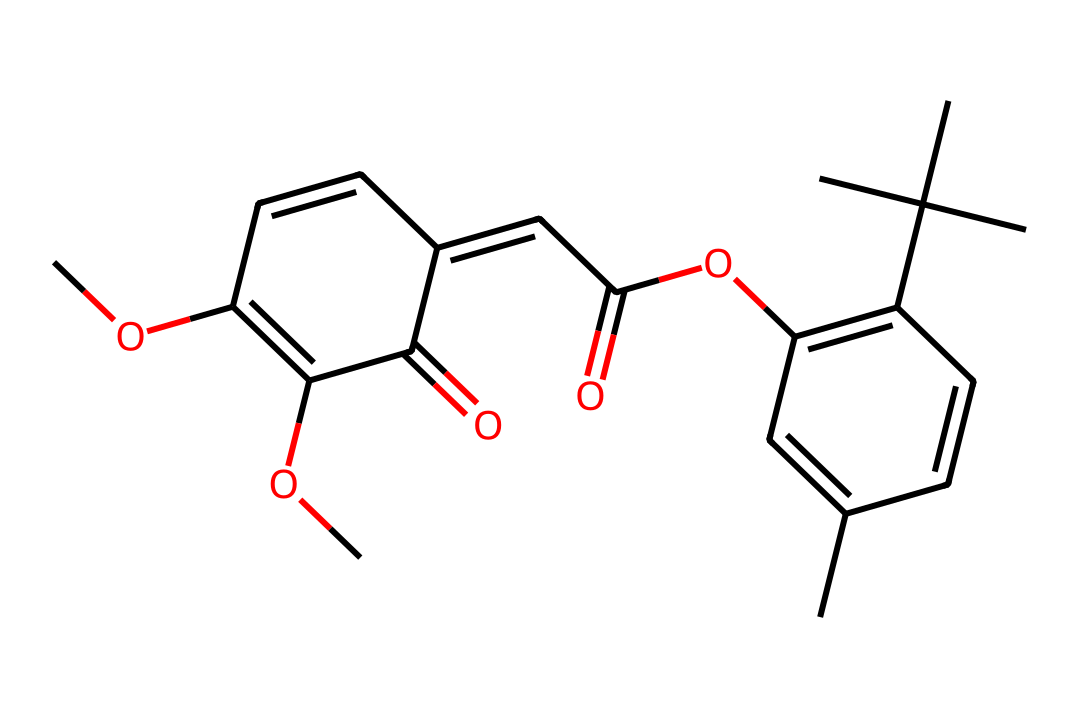What is the molecular formula of this compound? By analyzing the provided SMILES representation, we can count the number of each type of atom. The molecule contains 20 carbon atoms, 24 hydrogen atoms, and 6 oxygen atoms. Therefore, the molecular formula is C20H24O6.
Answer: C20H24O6 How many rings are present in this structure? The SMILES indicates multiple connections and cyclic structures. By tracing through the structure, we notice it contains two distinct cycles, identifiable from the numbering in the SMILES string.
Answer: 2 What functional groups can be identified in this compound? Looking closely at the structure, we can identify several functionalities: the presence of ester groups (C-O-C and C=O) and aromatic rings, which indicates that it has both ester and aromatic functional groups.
Answer: ester, aromatic What property enhances this photoresist's heat resistance? Examining the structure, we see that the presence of bulky side groups (the tert-butyl groups) and aromatic rings contributes significantly to thermal stability by preventing the chain mobility.
Answer: bulky groups, aromatic rings What is the main application of this type of photoresist? The characteristics of this chemical make it suitable for high-temperature applications, particularly in semiconductor technology and geothermal energy equipment, where stability at elevated temperatures is required.
Answer: semiconductor technology, geothermal energy How does the presence of double bonds impact the light sensitivity of this photoresist? The double bonds in the structure are critical for the photoresist's ability to undergo photopolymerization upon exposure to light, facilitating the formation of a cross-linked network.
Answer: photopolymerization What is the total number of oxygen atoms in this molecule? From counting in the SMILES representation, we find there are six oxygen atoms present in the molecular structure.
Answer: 6 